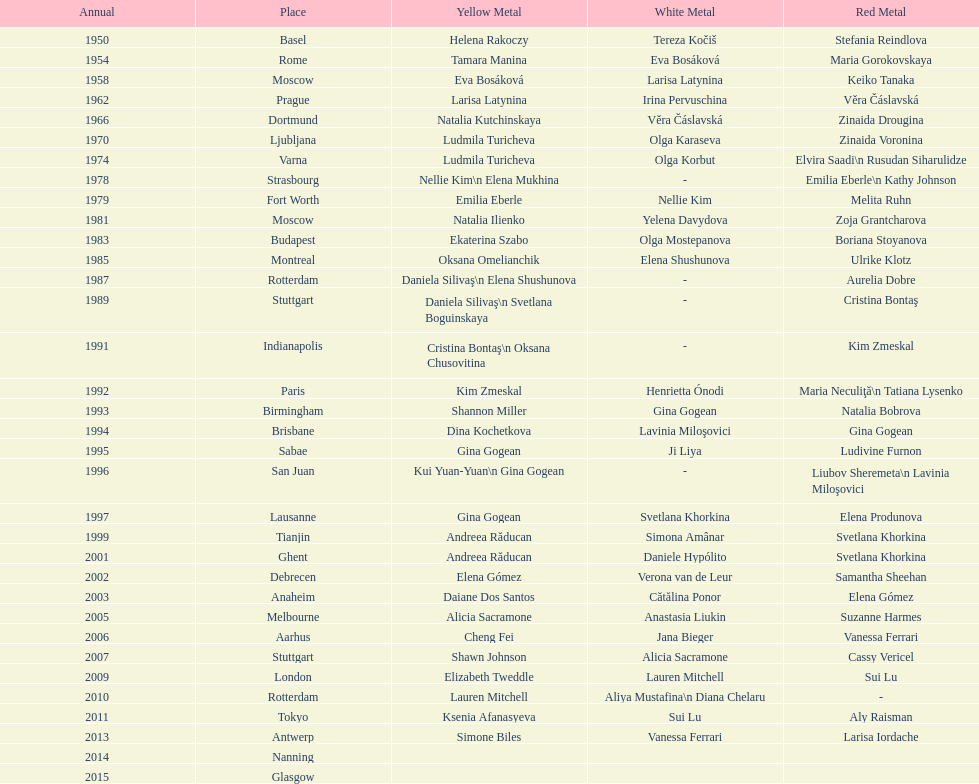Where were the championships held before the 1962 prague championships? Moscow. 